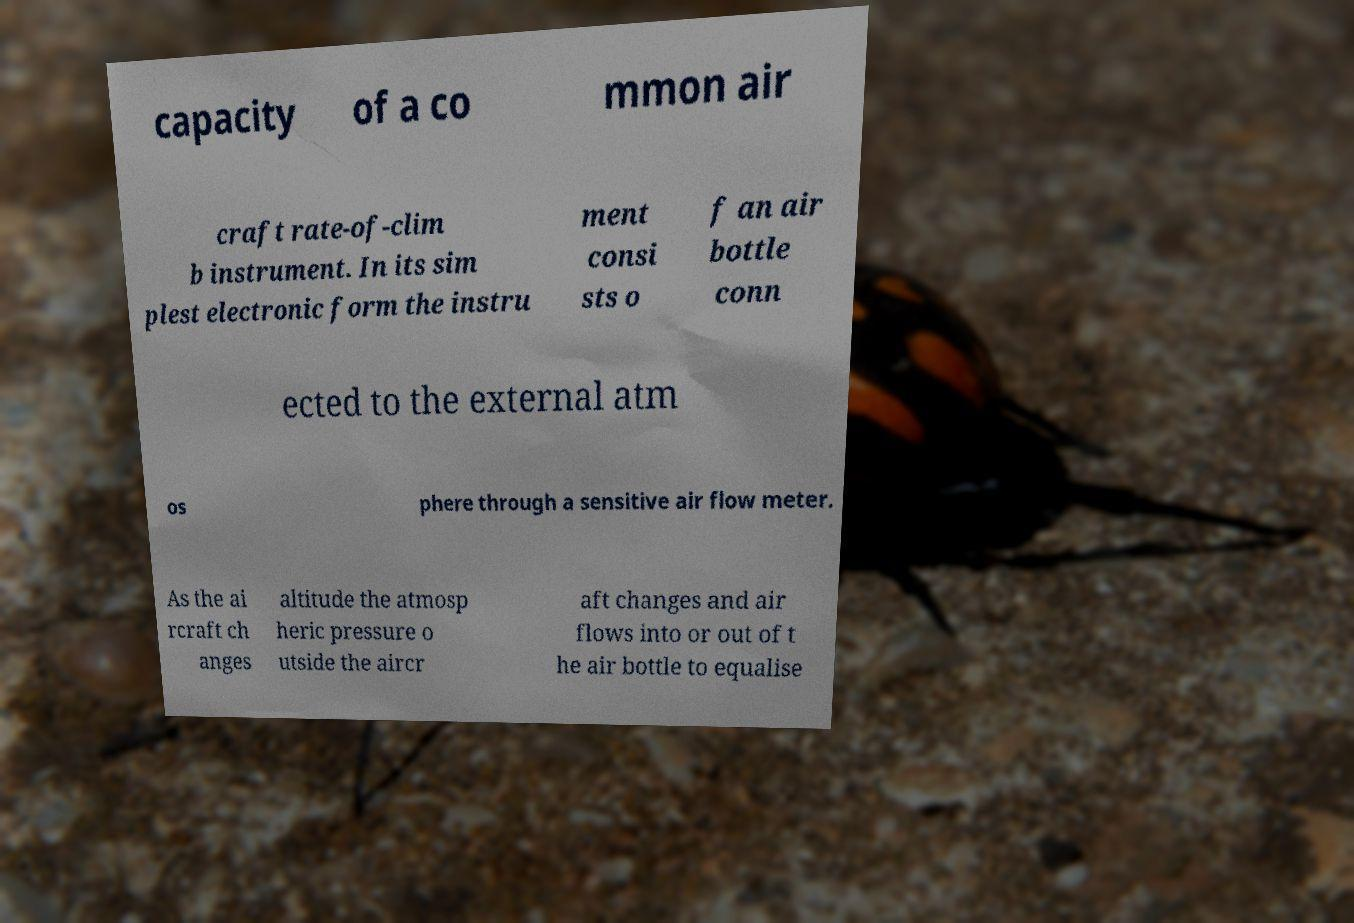Please read and relay the text visible in this image. What does it say? capacity of a co mmon air craft rate-of-clim b instrument. In its sim plest electronic form the instru ment consi sts o f an air bottle conn ected to the external atm os phere through a sensitive air flow meter. As the ai rcraft ch anges altitude the atmosp heric pressure o utside the aircr aft changes and air flows into or out of t he air bottle to equalise 